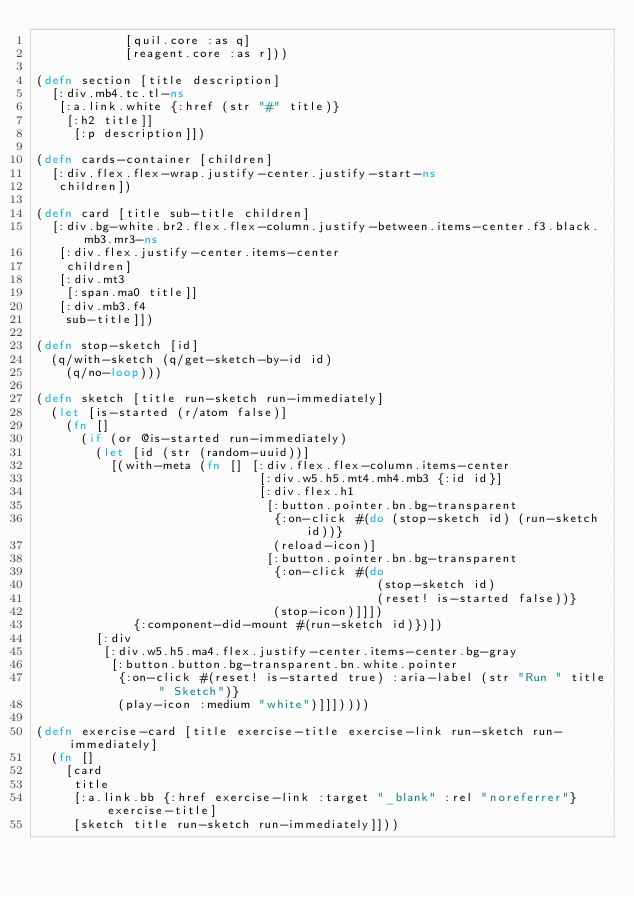<code> <loc_0><loc_0><loc_500><loc_500><_Clojure_>            [quil.core :as q]
            [reagent.core :as r]))

(defn section [title description]
  [:div.mb4.tc.tl-ns
   [:a.link.white {:href (str "#" title)}
    [:h2 title]]
     [:p description]])

(defn cards-container [children]
  [:div.flex.flex-wrap.justify-center.justify-start-ns
   children])

(defn card [title sub-title children]
  [:div.bg-white.br2.flex.flex-column.justify-between.items-center.f3.black.mb3.mr3-ns
   [:div.flex.justify-center.items-center
    children]
   [:div.mt3
    [:span.ma0 title]]
   [:div.mb3.f4
    sub-title]])

(defn stop-sketch [id]
  (q/with-sketch (q/get-sketch-by-id id)
    (q/no-loop)))

(defn sketch [title run-sketch run-immediately]
  (let [is-started (r/atom false)]
    (fn []
      (if (or @is-started run-immediately)
        (let [id (str (random-uuid))]
          [(with-meta (fn [] [:div.flex.flex-column.items-center
                              [:div.w5.h5.mt4.mh4.mb3 {:id id}]
                              [:div.flex.h1
                               [:button.pointer.bn.bg-transparent
                                {:on-click #(do (stop-sketch id) (run-sketch id))}
                                (reload-icon)]
                               [:button.pointer.bn.bg-transparent
                                {:on-click #(do
                                              (stop-sketch id)
                                              (reset! is-started false))}
                                (stop-icon)]]])
             {:component-did-mount #(run-sketch id)})])
        [:div
         [:div.w5.h5.ma4.flex.justify-center.items-center.bg-gray
          [:button.button.bg-transparent.bn.white.pointer
           {:on-click #(reset! is-started true) :aria-label (str "Run " title " Sketch")}
           (play-icon :medium "white")]]]))))

(defn exercise-card [title exercise-title exercise-link run-sketch run-immediately]
  (fn []
    [card
     title
     [:a.link.bb {:href exercise-link :target "_blank" :rel "noreferrer"} exercise-title]
     [sketch title run-sketch run-immediately]]))
</code> 